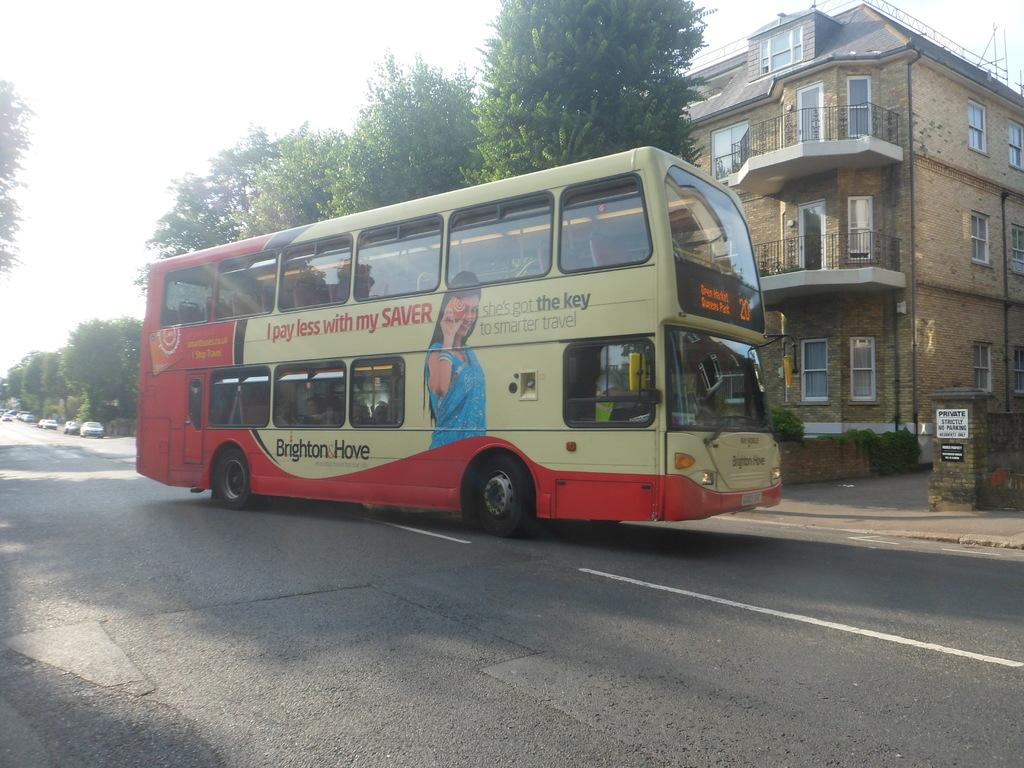What type of vehicle is on the road in the image? There is a double-decker bus on the road in the image. What can be seen in the background of the image? There is a building in the background of the image. What type of vegetation is near the building? There are trees beside the building. What else is on the road besides the double-decker bus? There are cars on the road. What color is the skirt worn by the mice in the image? There are no mice or skirts present in the image. How is the string used in the image? There is no string present in the image. 